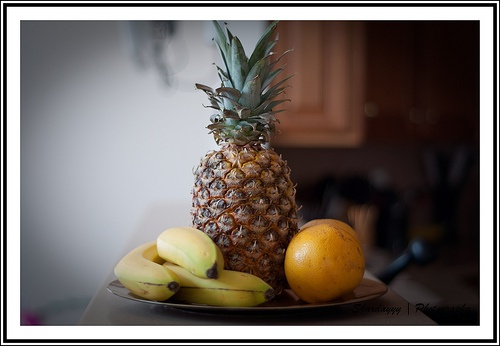Describe the objects in this image and their specific colors. I can see dining table in black, gray, lightgray, and darkgray tones, banana in black, tan, olive, and khaki tones, and orange in black, olive, maroon, orange, and tan tones in this image. 